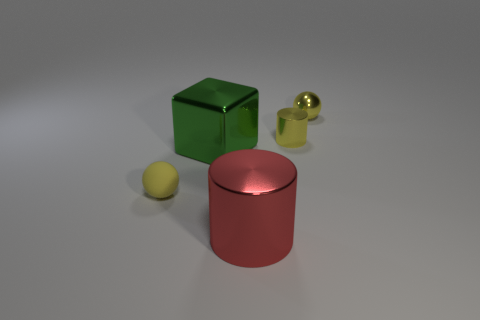Add 1 small yellow metallic cylinders. How many objects exist? 6 Subtract all cylinders. How many objects are left? 3 Add 4 big shiny cylinders. How many big shiny cylinders are left? 5 Add 1 yellow rubber objects. How many yellow rubber objects exist? 2 Subtract 0 green cylinders. How many objects are left? 5 Subtract all red objects. Subtract all cylinders. How many objects are left? 2 